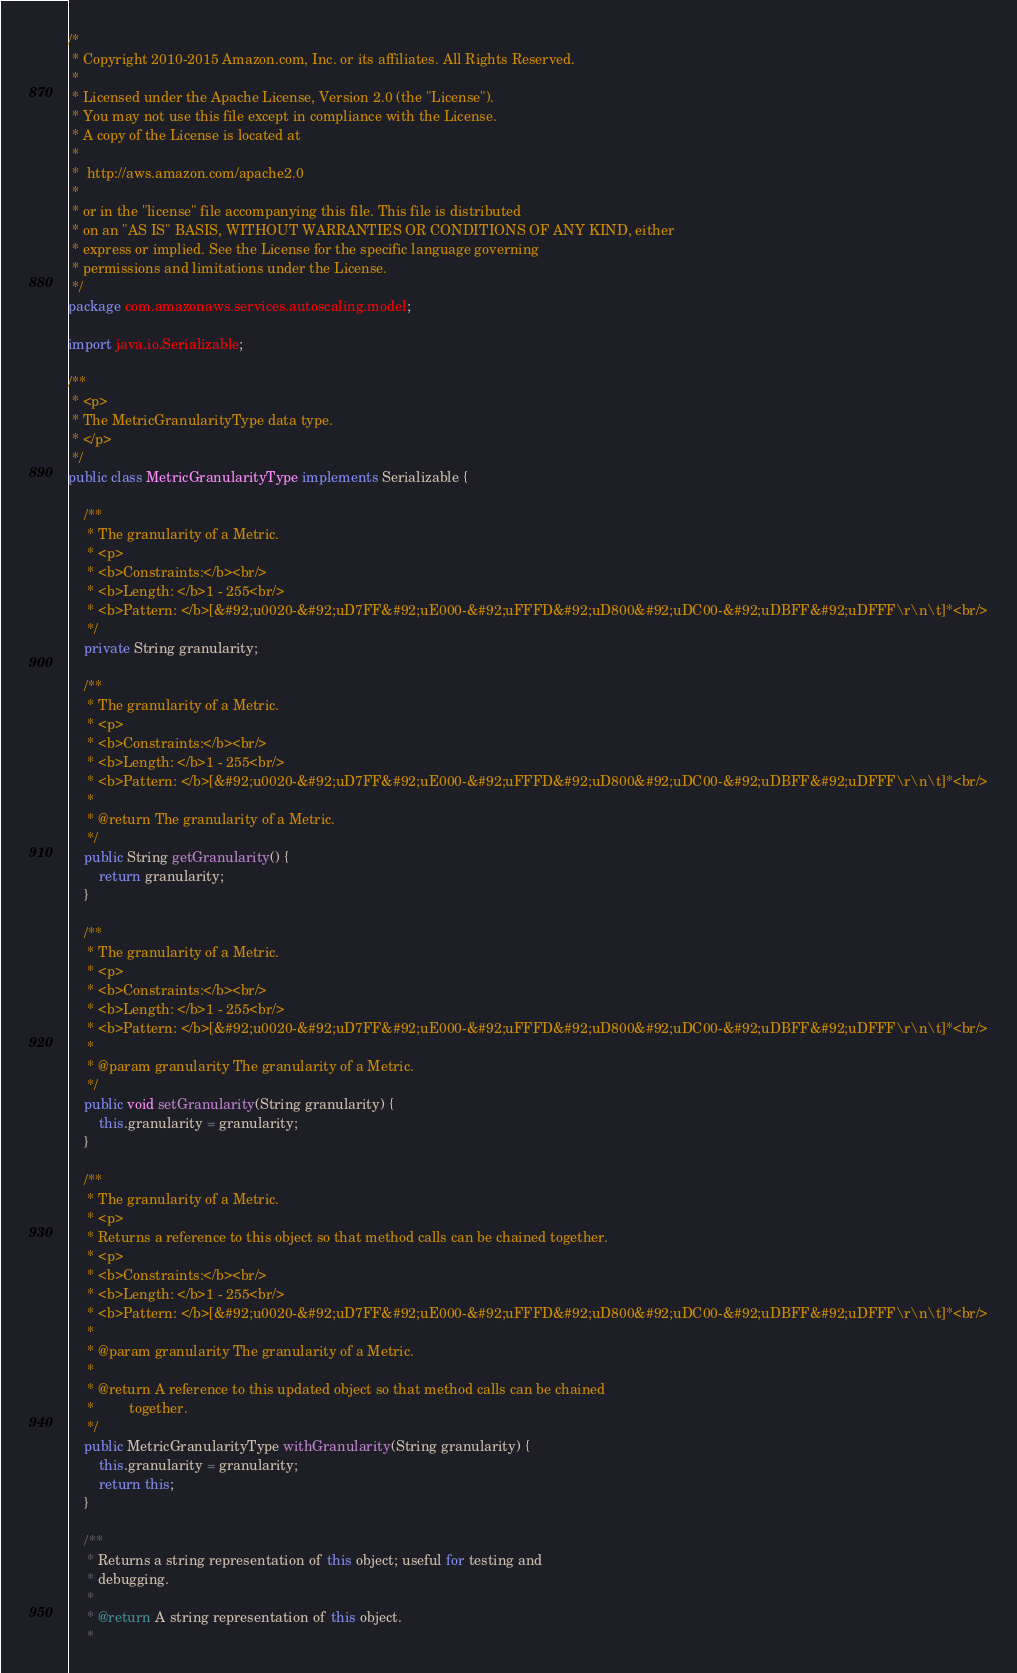Convert code to text. <code><loc_0><loc_0><loc_500><loc_500><_Java_>/*
 * Copyright 2010-2015 Amazon.com, Inc. or its affiliates. All Rights Reserved.
 * 
 * Licensed under the Apache License, Version 2.0 (the "License").
 * You may not use this file except in compliance with the License.
 * A copy of the License is located at
 * 
 *  http://aws.amazon.com/apache2.0
 * 
 * or in the "license" file accompanying this file. This file is distributed
 * on an "AS IS" BASIS, WITHOUT WARRANTIES OR CONDITIONS OF ANY KIND, either
 * express or implied. See the License for the specific language governing
 * permissions and limitations under the License.
 */
package com.amazonaws.services.autoscaling.model;

import java.io.Serializable;

/**
 * <p>
 * The MetricGranularityType data type.
 * </p>
 */
public class MetricGranularityType implements Serializable {

    /**
     * The granularity of a Metric.
     * <p>
     * <b>Constraints:</b><br/>
     * <b>Length: </b>1 - 255<br/>
     * <b>Pattern: </b>[&#92;u0020-&#92;uD7FF&#92;uE000-&#92;uFFFD&#92;uD800&#92;uDC00-&#92;uDBFF&#92;uDFFF\r\n\t]*<br/>
     */
    private String granularity;

    /**
     * The granularity of a Metric.
     * <p>
     * <b>Constraints:</b><br/>
     * <b>Length: </b>1 - 255<br/>
     * <b>Pattern: </b>[&#92;u0020-&#92;uD7FF&#92;uE000-&#92;uFFFD&#92;uD800&#92;uDC00-&#92;uDBFF&#92;uDFFF\r\n\t]*<br/>
     *
     * @return The granularity of a Metric.
     */
    public String getGranularity() {
        return granularity;
    }
    
    /**
     * The granularity of a Metric.
     * <p>
     * <b>Constraints:</b><br/>
     * <b>Length: </b>1 - 255<br/>
     * <b>Pattern: </b>[&#92;u0020-&#92;uD7FF&#92;uE000-&#92;uFFFD&#92;uD800&#92;uDC00-&#92;uDBFF&#92;uDFFF\r\n\t]*<br/>
     *
     * @param granularity The granularity of a Metric.
     */
    public void setGranularity(String granularity) {
        this.granularity = granularity;
    }
    
    /**
     * The granularity of a Metric.
     * <p>
     * Returns a reference to this object so that method calls can be chained together.
     * <p>
     * <b>Constraints:</b><br/>
     * <b>Length: </b>1 - 255<br/>
     * <b>Pattern: </b>[&#92;u0020-&#92;uD7FF&#92;uE000-&#92;uFFFD&#92;uD800&#92;uDC00-&#92;uDBFF&#92;uDFFF\r\n\t]*<br/>
     *
     * @param granularity The granularity of a Metric.
     *
     * @return A reference to this updated object so that method calls can be chained
     *         together.
     */
    public MetricGranularityType withGranularity(String granularity) {
        this.granularity = granularity;
        return this;
    }

    /**
     * Returns a string representation of this object; useful for testing and
     * debugging.
     *
     * @return A string representation of this object.
     *</code> 